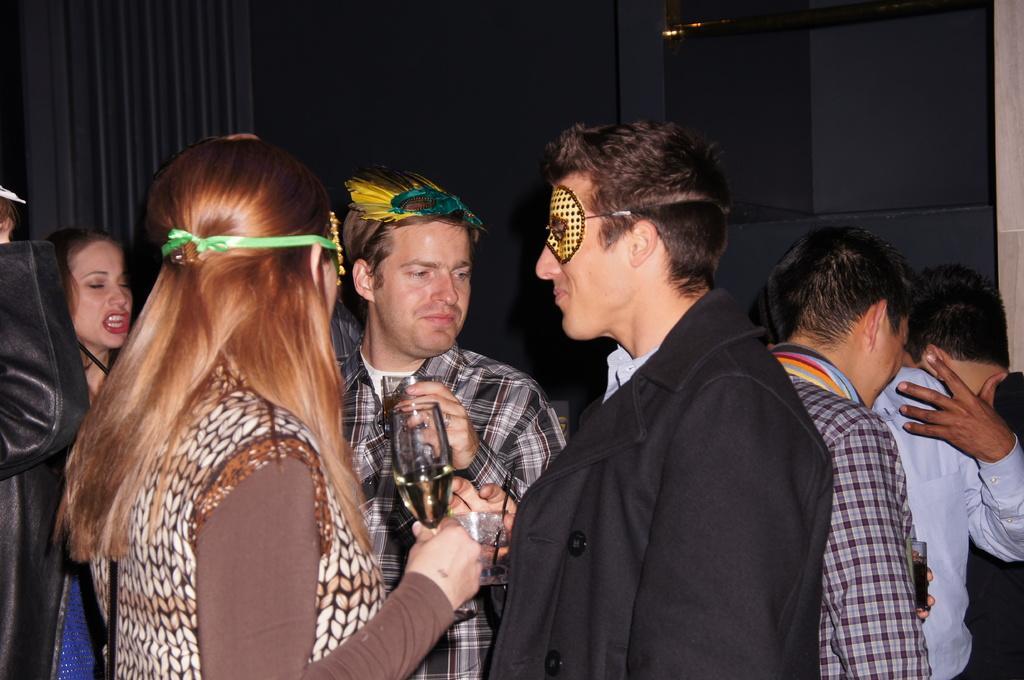Could you give a brief overview of what you see in this image? In this picture there is a woman standing and holding the glass and there is a person standing and glass. At the back there are group of people standing and there is a curtain. 